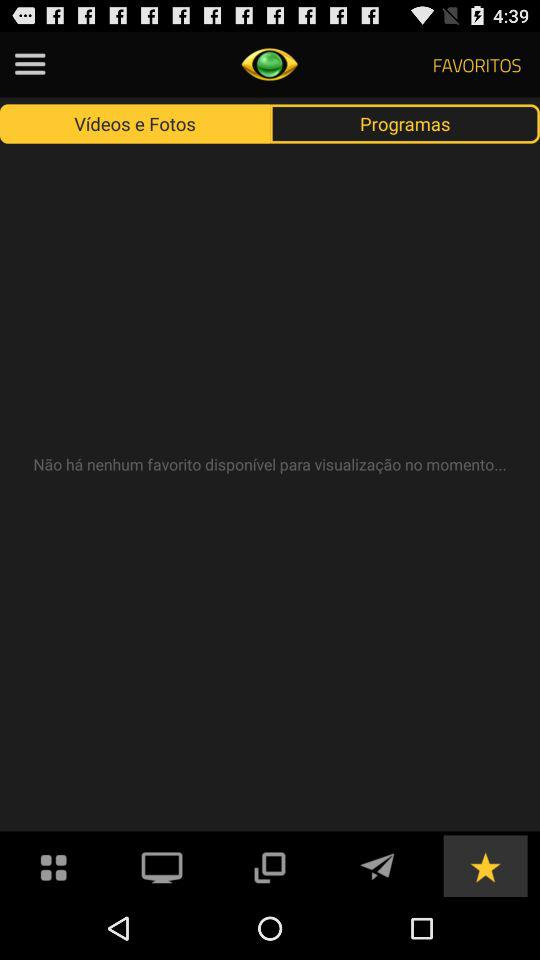Which button has been selected in the bottom row? The button that has been selected in the bottom row is "starred". 